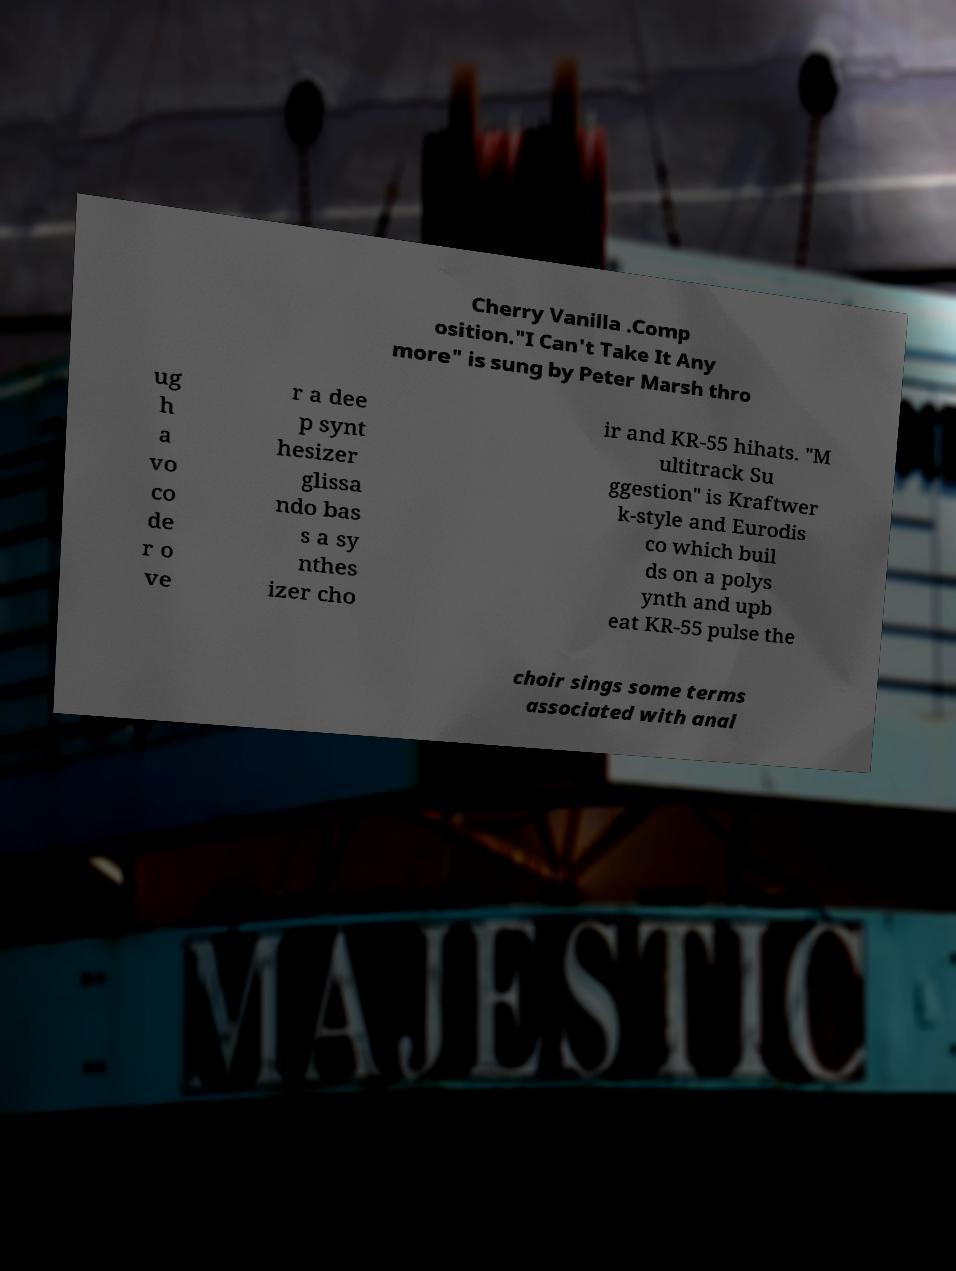Can you accurately transcribe the text from the provided image for me? Cherry Vanilla .Comp osition."I Can't Take It Any more" is sung by Peter Marsh thro ug h a vo co de r o ve r a dee p synt hesizer glissa ndo bas s a sy nthes izer cho ir and KR-55 hihats. "M ultitrack Su ggestion" is Kraftwer k-style and Eurodis co which buil ds on a polys ynth and upb eat KR-55 pulse the choir sings some terms associated with anal 